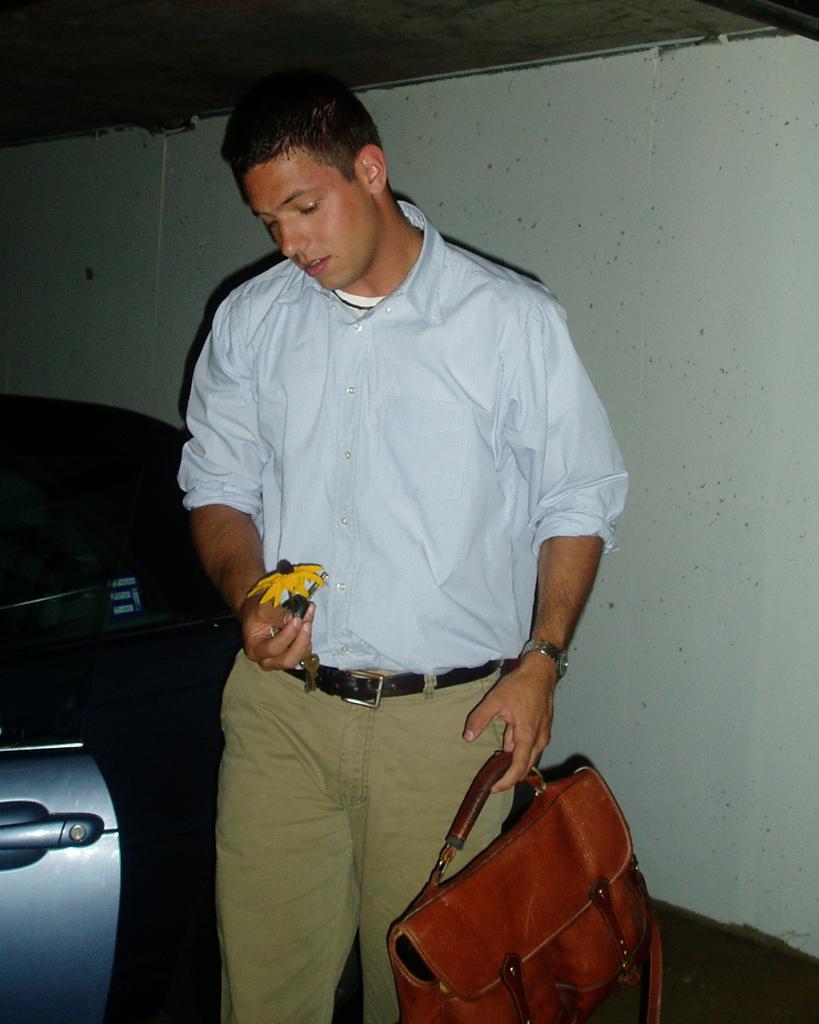How would you summarize this image in a sentence or two? The person wearing blue shirt is holding a bag in his left hand and a flower in his right hand and there is a blue car beside him. 